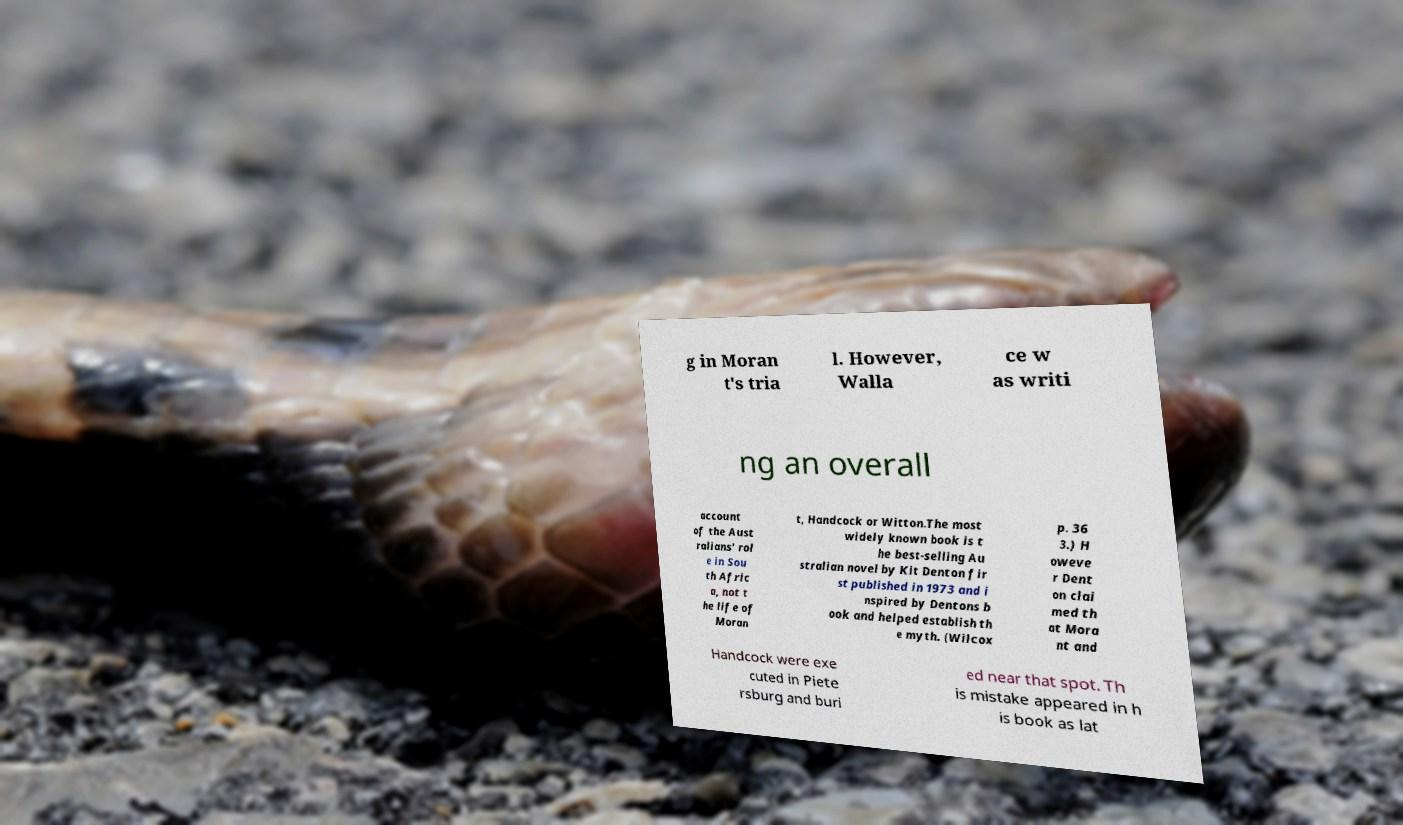What messages or text are displayed in this image? I need them in a readable, typed format. g in Moran t's tria l. However, Walla ce w as writi ng an overall account of the Aust ralians' rol e in Sou th Afric a, not t he life of Moran t, Handcock or Witton.The most widely known book is t he best-selling Au stralian novel by Kit Denton fir st published in 1973 and i nspired by Dentons b ook and helped establish th e myth. (Wilcox p. 36 3.) H oweve r Dent on clai med th at Mora nt and Handcock were exe cuted in Piete rsburg and buri ed near that spot. Th is mistake appeared in h is book as lat 